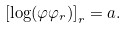<formula> <loc_0><loc_0><loc_500><loc_500>\left [ \log ( \varphi \varphi _ { r } ) \right ] _ { r } = a .</formula> 